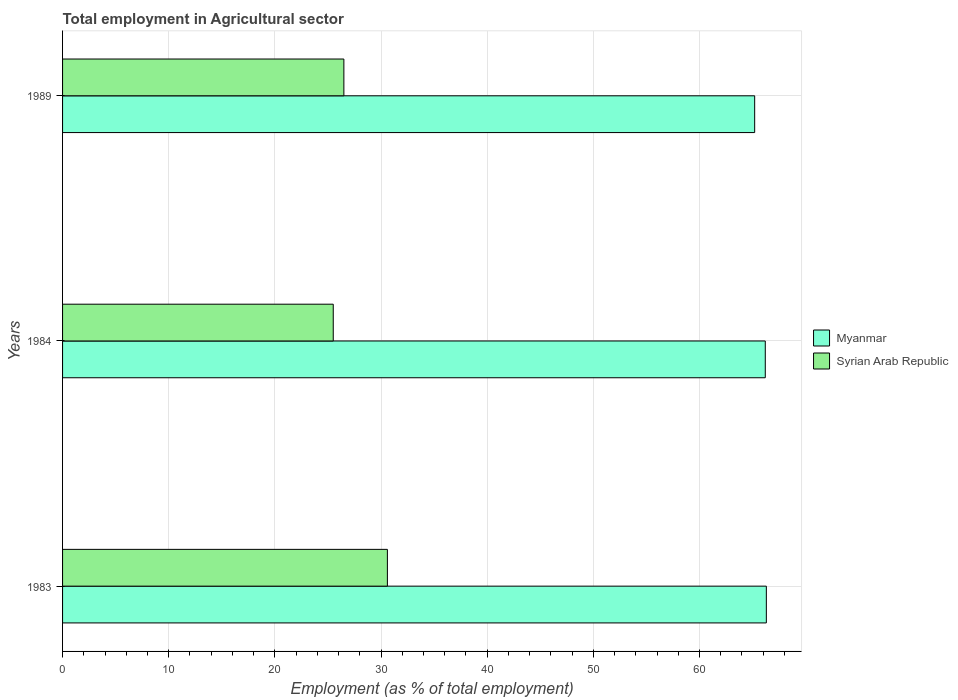Are the number of bars on each tick of the Y-axis equal?
Ensure brevity in your answer.  Yes. How many bars are there on the 2nd tick from the bottom?
Your answer should be very brief. 2. What is the employment in agricultural sector in Syrian Arab Republic in 1983?
Ensure brevity in your answer.  30.6. Across all years, what is the maximum employment in agricultural sector in Myanmar?
Offer a very short reply. 66.3. Across all years, what is the minimum employment in agricultural sector in Myanmar?
Offer a very short reply. 65.2. What is the total employment in agricultural sector in Myanmar in the graph?
Keep it short and to the point. 197.7. What is the difference between the employment in agricultural sector in Syrian Arab Republic in 1983 and the employment in agricultural sector in Myanmar in 1989?
Provide a short and direct response. -34.6. What is the average employment in agricultural sector in Syrian Arab Republic per year?
Provide a succinct answer. 27.53. In the year 1984, what is the difference between the employment in agricultural sector in Myanmar and employment in agricultural sector in Syrian Arab Republic?
Your answer should be compact. 40.7. What is the ratio of the employment in agricultural sector in Syrian Arab Republic in 1983 to that in 1984?
Provide a short and direct response. 1.2. Is the difference between the employment in agricultural sector in Myanmar in 1983 and 1984 greater than the difference between the employment in agricultural sector in Syrian Arab Republic in 1983 and 1984?
Your answer should be compact. No. What is the difference between the highest and the second highest employment in agricultural sector in Myanmar?
Keep it short and to the point. 0.1. What is the difference between the highest and the lowest employment in agricultural sector in Syrian Arab Republic?
Offer a very short reply. 5.1. In how many years, is the employment in agricultural sector in Myanmar greater than the average employment in agricultural sector in Myanmar taken over all years?
Your response must be concise. 2. Is the sum of the employment in agricultural sector in Myanmar in 1983 and 1984 greater than the maximum employment in agricultural sector in Syrian Arab Republic across all years?
Your response must be concise. Yes. What does the 1st bar from the top in 1989 represents?
Your answer should be very brief. Syrian Arab Republic. What does the 1st bar from the bottom in 1983 represents?
Ensure brevity in your answer.  Myanmar. How many bars are there?
Give a very brief answer. 6. Are the values on the major ticks of X-axis written in scientific E-notation?
Offer a very short reply. No. Where does the legend appear in the graph?
Provide a short and direct response. Center right. How many legend labels are there?
Your answer should be very brief. 2. What is the title of the graph?
Provide a short and direct response. Total employment in Agricultural sector. Does "Nepal" appear as one of the legend labels in the graph?
Make the answer very short. No. What is the label or title of the X-axis?
Offer a very short reply. Employment (as % of total employment). What is the label or title of the Y-axis?
Give a very brief answer. Years. What is the Employment (as % of total employment) in Myanmar in 1983?
Provide a succinct answer. 66.3. What is the Employment (as % of total employment) in Syrian Arab Republic in 1983?
Offer a terse response. 30.6. What is the Employment (as % of total employment) of Myanmar in 1984?
Ensure brevity in your answer.  66.2. What is the Employment (as % of total employment) of Myanmar in 1989?
Provide a short and direct response. 65.2. What is the Employment (as % of total employment) in Syrian Arab Republic in 1989?
Ensure brevity in your answer.  26.5. Across all years, what is the maximum Employment (as % of total employment) of Myanmar?
Give a very brief answer. 66.3. Across all years, what is the maximum Employment (as % of total employment) of Syrian Arab Republic?
Give a very brief answer. 30.6. Across all years, what is the minimum Employment (as % of total employment) in Myanmar?
Make the answer very short. 65.2. Across all years, what is the minimum Employment (as % of total employment) in Syrian Arab Republic?
Provide a succinct answer. 25.5. What is the total Employment (as % of total employment) in Myanmar in the graph?
Your answer should be very brief. 197.7. What is the total Employment (as % of total employment) in Syrian Arab Republic in the graph?
Your response must be concise. 82.6. What is the difference between the Employment (as % of total employment) in Myanmar in 1984 and that in 1989?
Offer a terse response. 1. What is the difference between the Employment (as % of total employment) in Myanmar in 1983 and the Employment (as % of total employment) in Syrian Arab Republic in 1984?
Provide a short and direct response. 40.8. What is the difference between the Employment (as % of total employment) of Myanmar in 1983 and the Employment (as % of total employment) of Syrian Arab Republic in 1989?
Ensure brevity in your answer.  39.8. What is the difference between the Employment (as % of total employment) in Myanmar in 1984 and the Employment (as % of total employment) in Syrian Arab Republic in 1989?
Give a very brief answer. 39.7. What is the average Employment (as % of total employment) of Myanmar per year?
Your answer should be compact. 65.9. What is the average Employment (as % of total employment) of Syrian Arab Republic per year?
Your response must be concise. 27.53. In the year 1983, what is the difference between the Employment (as % of total employment) in Myanmar and Employment (as % of total employment) in Syrian Arab Republic?
Make the answer very short. 35.7. In the year 1984, what is the difference between the Employment (as % of total employment) in Myanmar and Employment (as % of total employment) in Syrian Arab Republic?
Provide a succinct answer. 40.7. In the year 1989, what is the difference between the Employment (as % of total employment) in Myanmar and Employment (as % of total employment) in Syrian Arab Republic?
Your answer should be very brief. 38.7. What is the ratio of the Employment (as % of total employment) of Myanmar in 1983 to that in 1984?
Keep it short and to the point. 1. What is the ratio of the Employment (as % of total employment) in Myanmar in 1983 to that in 1989?
Your answer should be very brief. 1.02. What is the ratio of the Employment (as % of total employment) in Syrian Arab Republic in 1983 to that in 1989?
Provide a short and direct response. 1.15. What is the ratio of the Employment (as % of total employment) of Myanmar in 1984 to that in 1989?
Keep it short and to the point. 1.02. What is the ratio of the Employment (as % of total employment) of Syrian Arab Republic in 1984 to that in 1989?
Ensure brevity in your answer.  0.96. What is the difference between the highest and the second highest Employment (as % of total employment) of Syrian Arab Republic?
Give a very brief answer. 4.1. What is the difference between the highest and the lowest Employment (as % of total employment) in Myanmar?
Offer a terse response. 1.1. What is the difference between the highest and the lowest Employment (as % of total employment) of Syrian Arab Republic?
Keep it short and to the point. 5.1. 